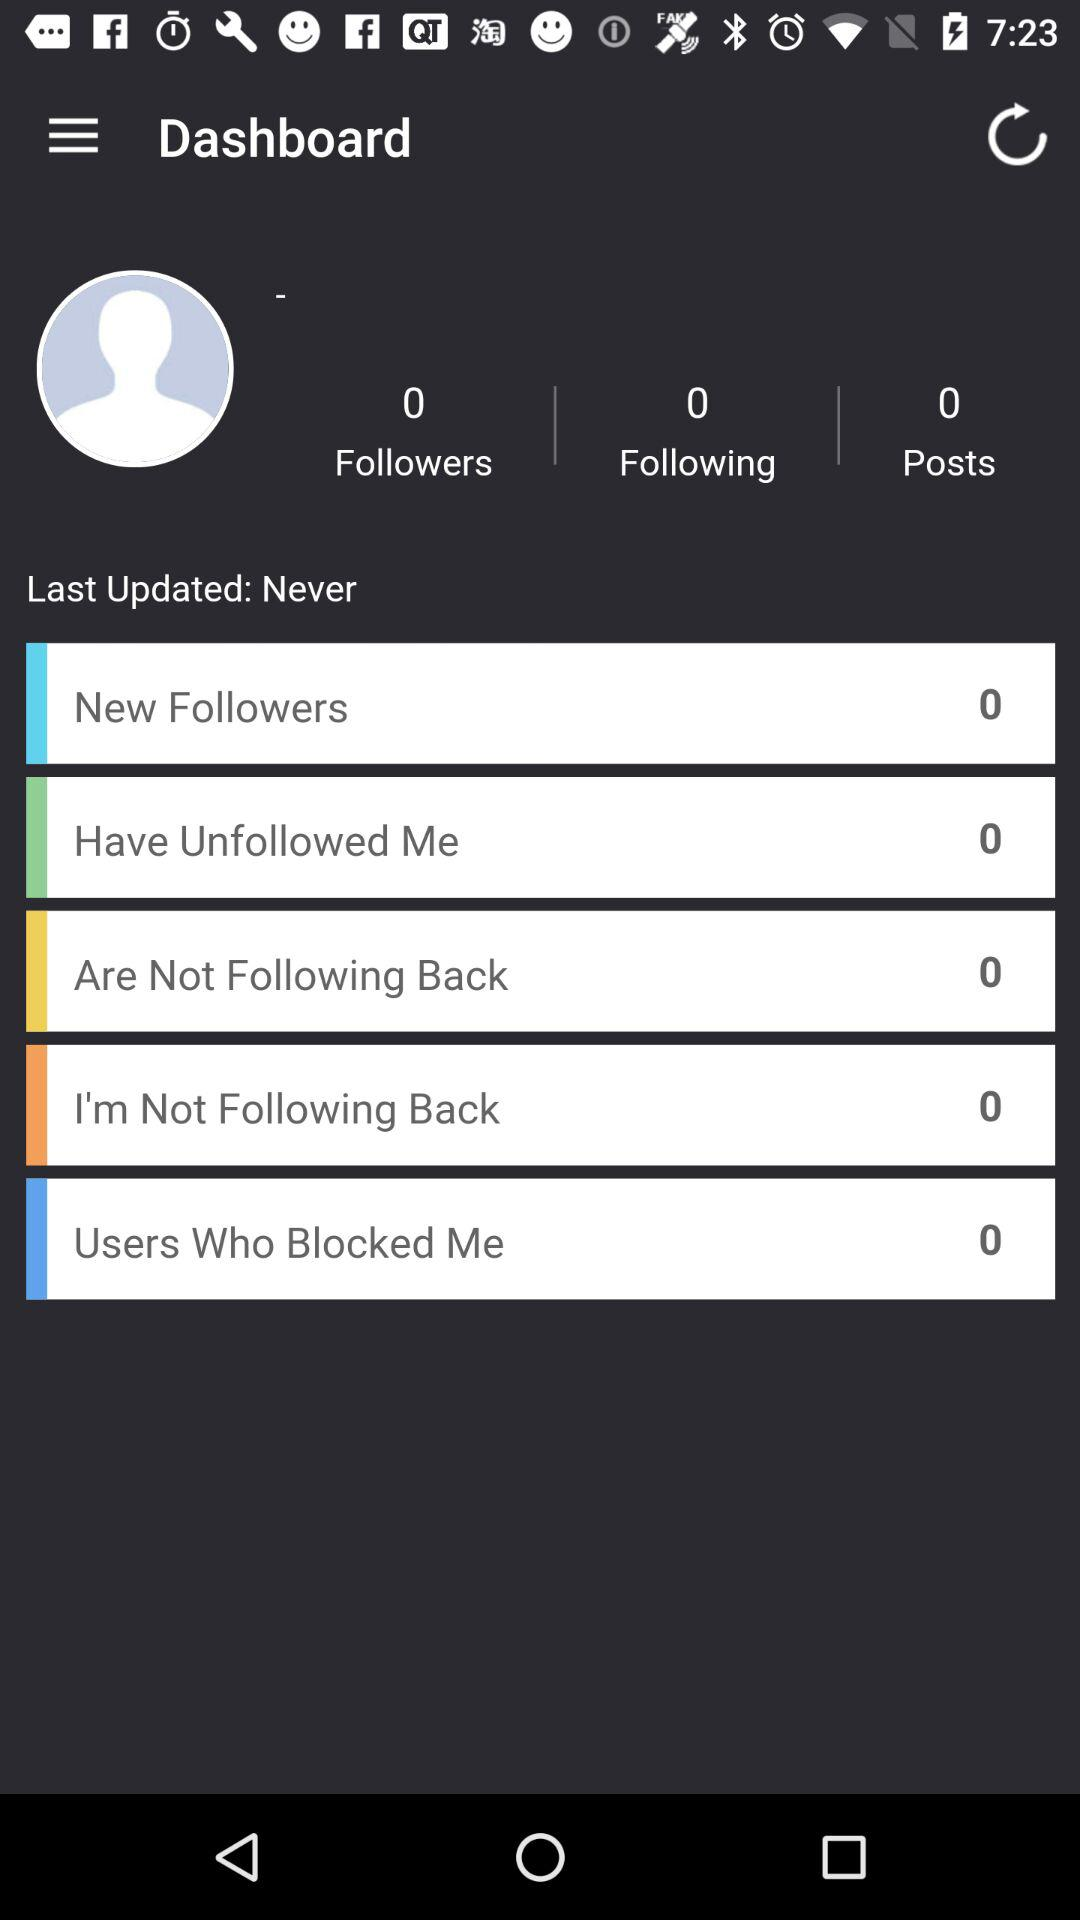How many followers are there? There are 0 followers. 